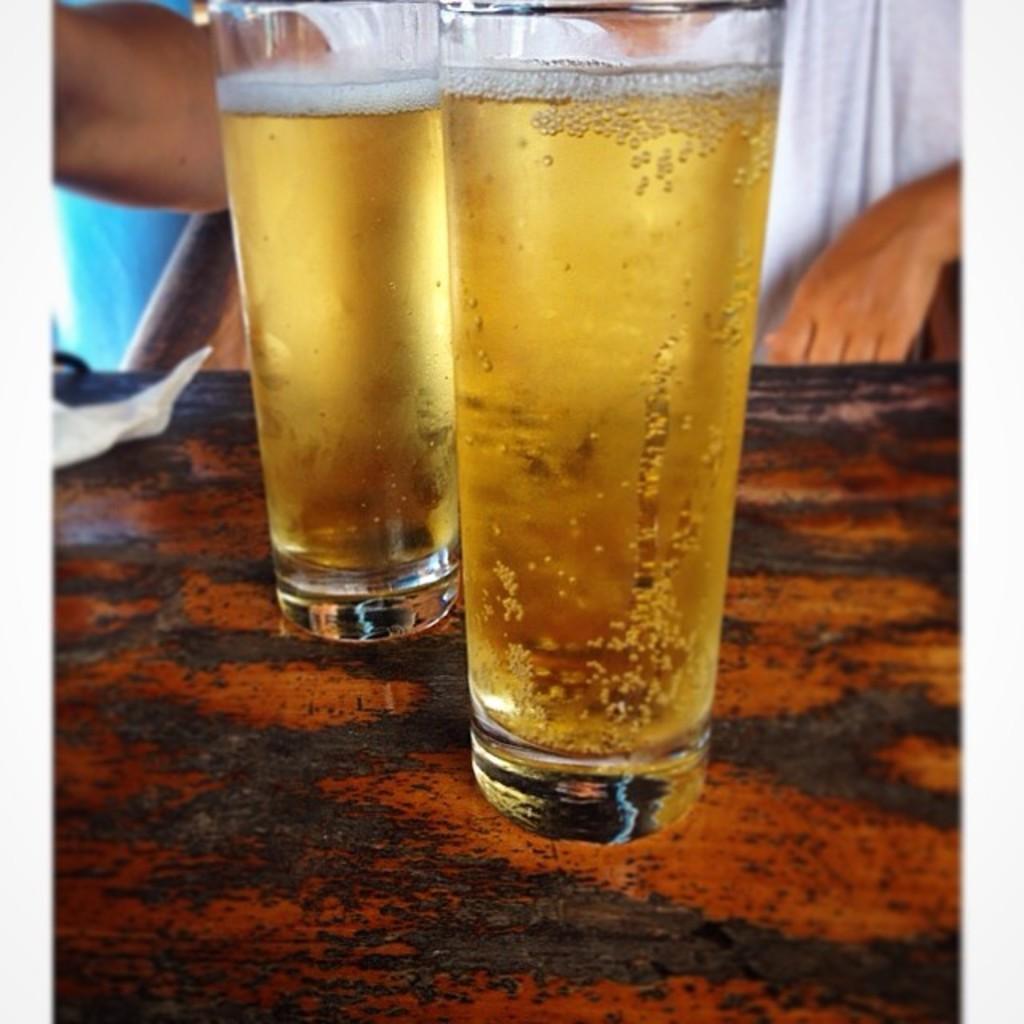Can you describe this image briefly? In this image, there are glass with liquids on the wooden surface. In the background, we can see a person sitting on a chair. On the left side of the image, we can see a paper and blue color object. 